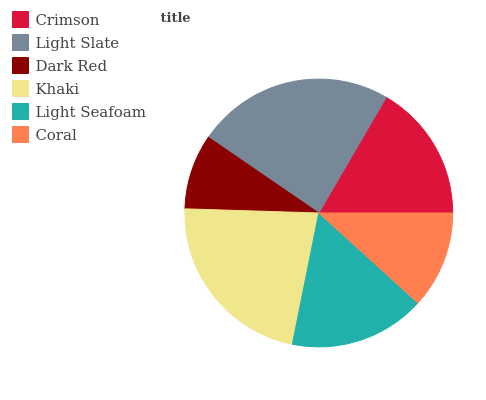Is Dark Red the minimum?
Answer yes or no. Yes. Is Light Slate the maximum?
Answer yes or no. Yes. Is Light Slate the minimum?
Answer yes or no. No. Is Dark Red the maximum?
Answer yes or no. No. Is Light Slate greater than Dark Red?
Answer yes or no. Yes. Is Dark Red less than Light Slate?
Answer yes or no. Yes. Is Dark Red greater than Light Slate?
Answer yes or no. No. Is Light Slate less than Dark Red?
Answer yes or no. No. Is Crimson the high median?
Answer yes or no. Yes. Is Light Seafoam the low median?
Answer yes or no. Yes. Is Khaki the high median?
Answer yes or no. No. Is Coral the low median?
Answer yes or no. No. 